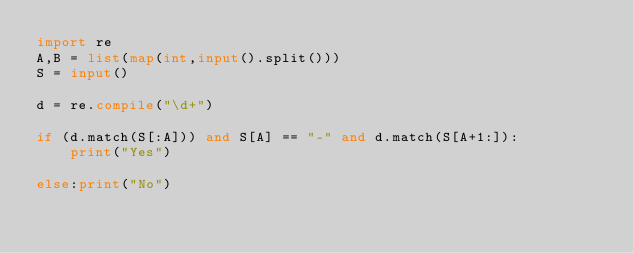<code> <loc_0><loc_0><loc_500><loc_500><_Python_>import re
A,B = list(map(int,input().split()))
S = input()

d = re.compile("\d+")

if (d.match(S[:A])) and S[A] == "-" and d.match(S[A+1:]):
    print("Yes")

else:print("No")
</code> 